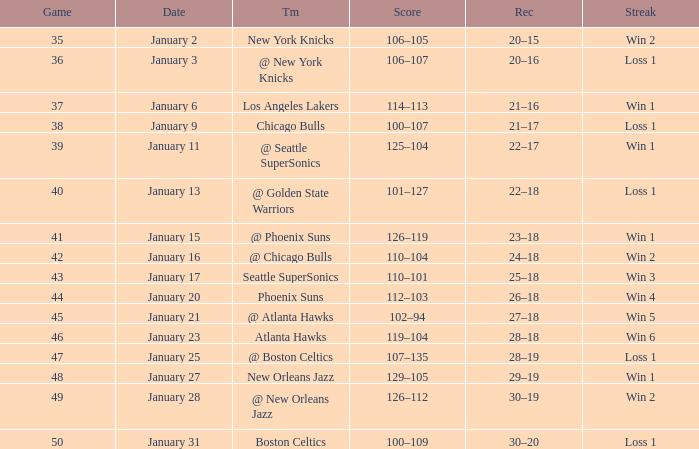What Game had a Score of 129–105? 48.0. 